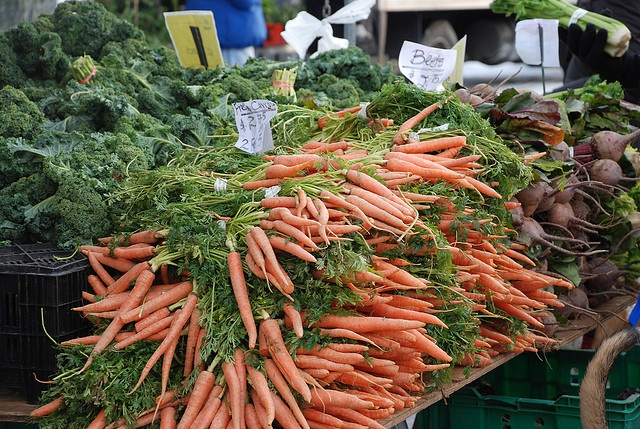Describe the objects in this image and their specific colors. I can see carrot in gray, black, darkgreen, brown, and maroon tones, broccoli in gray, darkgreen, black, and green tones, carrot in gray, salmon, and brown tones, broccoli in gray, black, and darkgreen tones, and broccoli in gray, teal, black, green, and darkgreen tones in this image. 